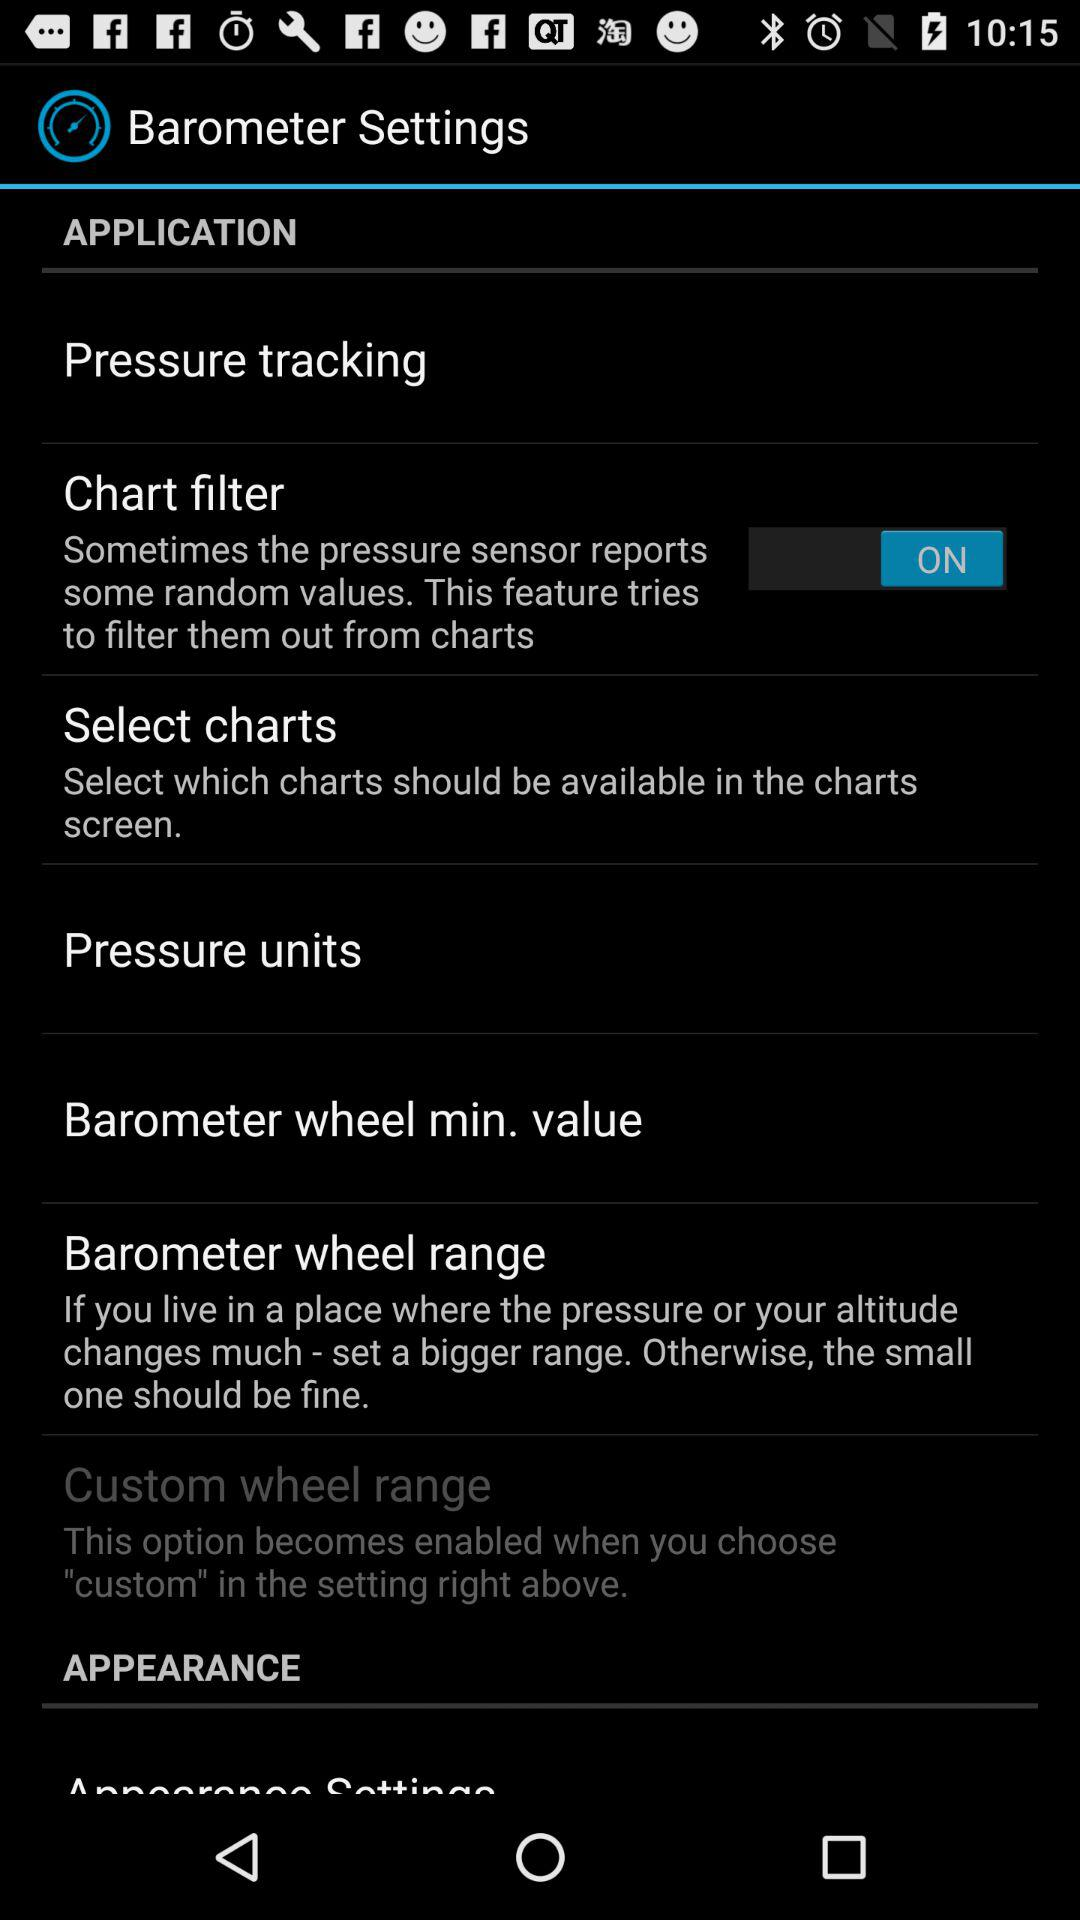What is the status of the "Chart filter"? The status in "ON". 